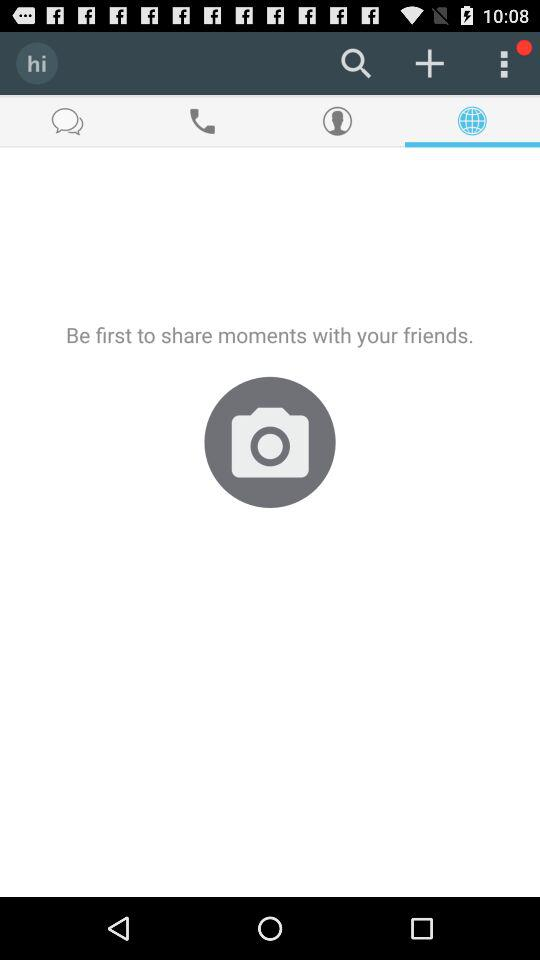Which tab is selected? The selected tab is "Globe". 